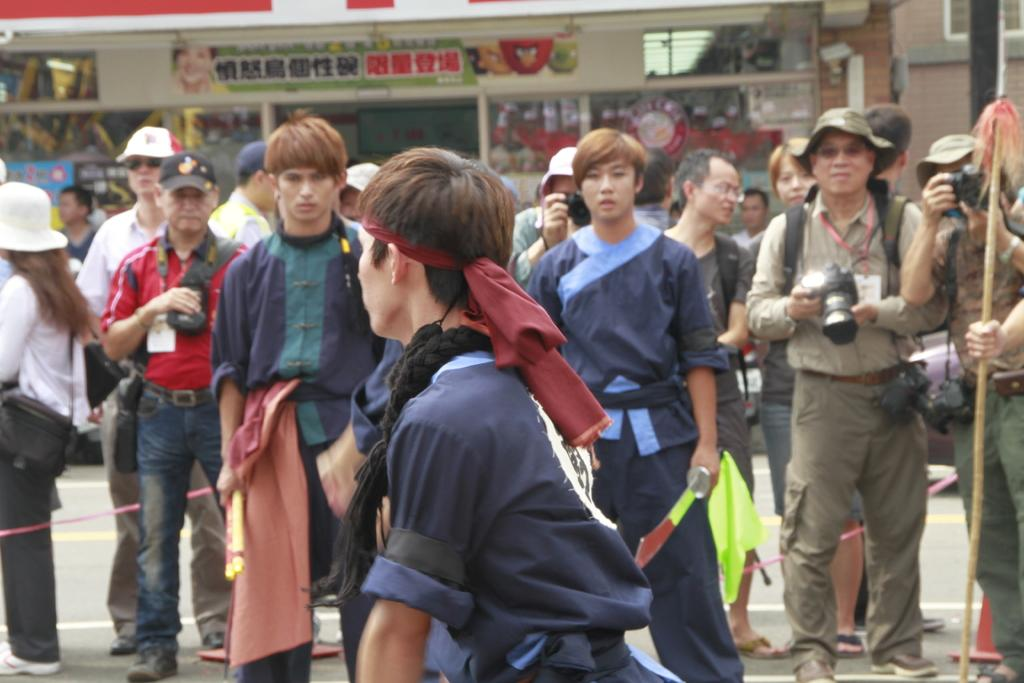What is the main subject of the image? There is a person standing in the center of the image. Can you describe the background of the image? In the background, there are a few persons standing. What are the persons in the background doing? The persons in the background are using a camera to take a picture. How does the person in the center of the image act when the persons in the background request to push them? There is no mention of the person in the center being requested to be pushed by the persons in the background, so this scenario cannot be answered from the given facts. 